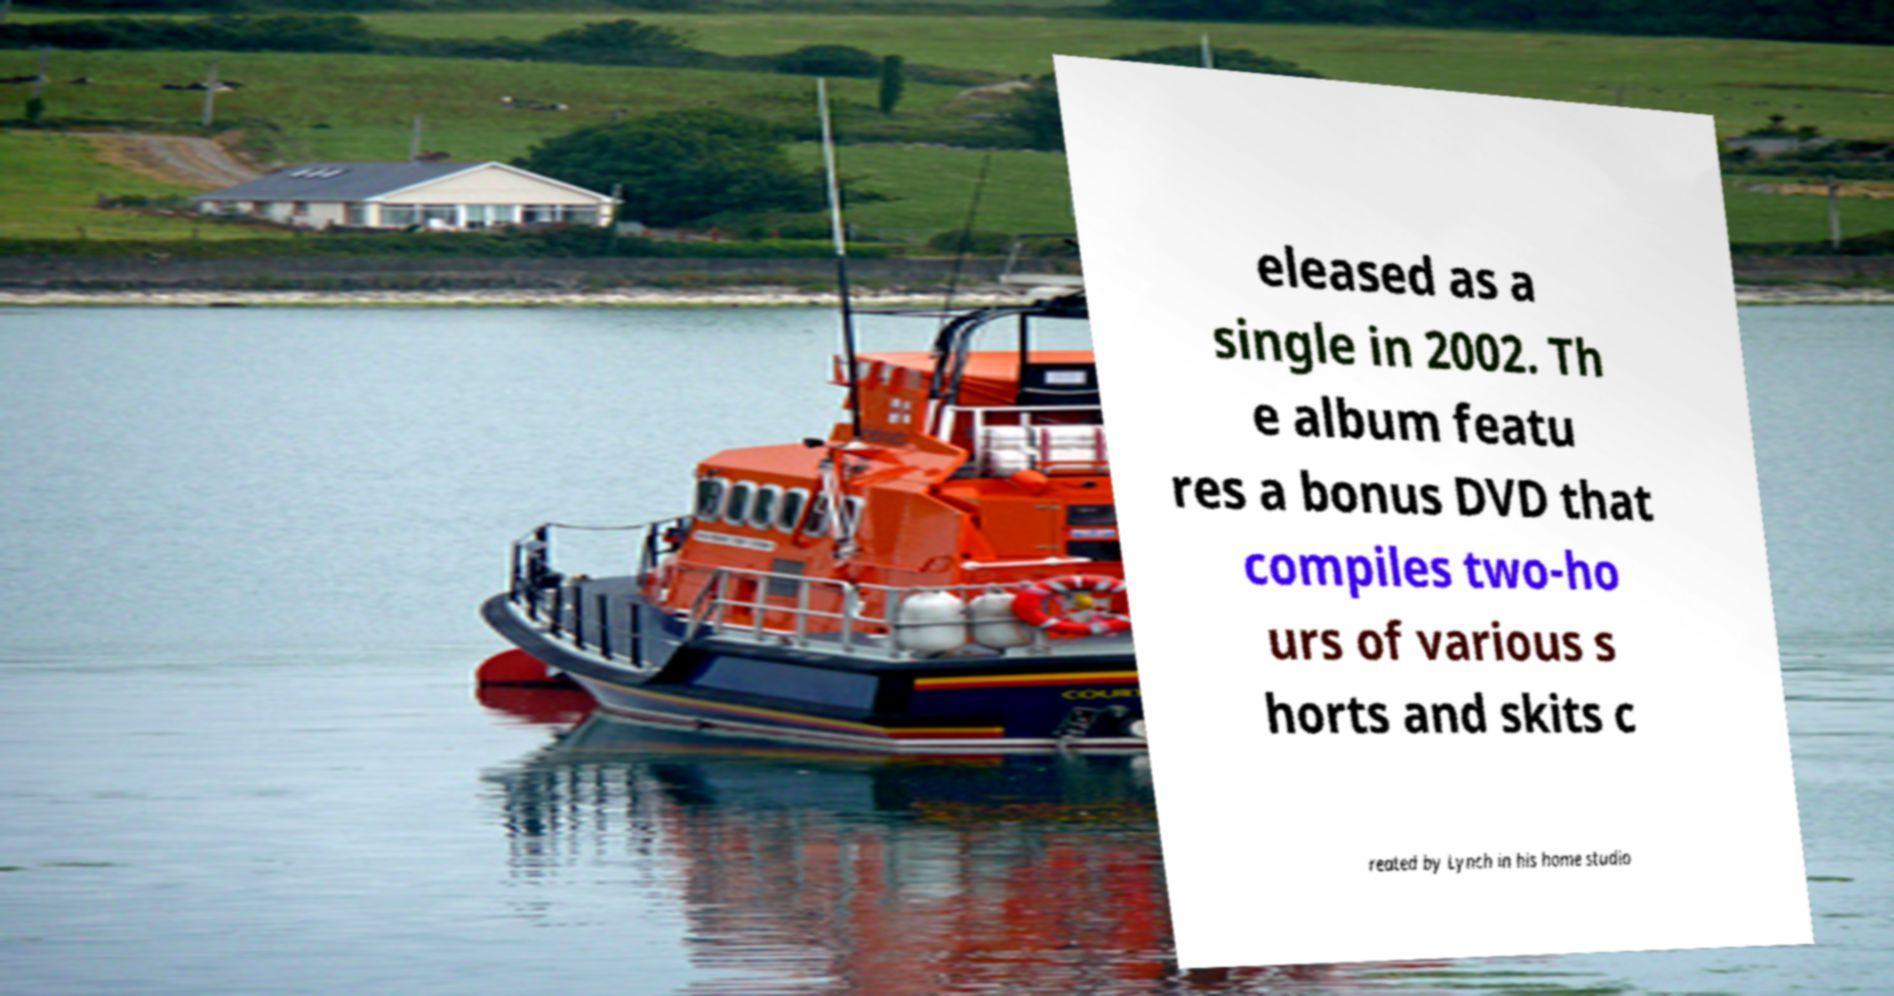Please identify and transcribe the text found in this image. eleased as a single in 2002. Th e album featu res a bonus DVD that compiles two-ho urs of various s horts and skits c reated by Lynch in his home studio 